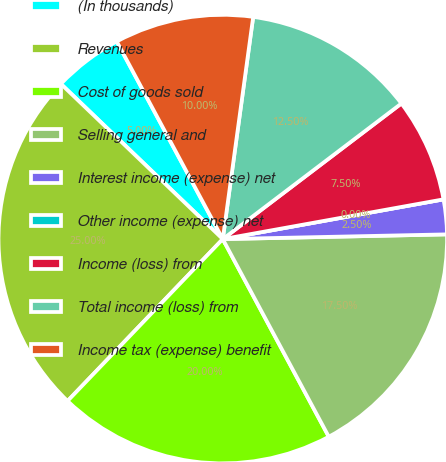Convert chart to OTSL. <chart><loc_0><loc_0><loc_500><loc_500><pie_chart><fcel>(In thousands)<fcel>Revenues<fcel>Cost of goods sold<fcel>Selling general and<fcel>Interest income (expense) net<fcel>Other income (expense) net<fcel>Income (loss) from<fcel>Total income (loss) from<fcel>Income tax (expense) benefit<nl><fcel>5.0%<fcel>25.0%<fcel>20.0%<fcel>17.5%<fcel>2.5%<fcel>0.0%<fcel>7.5%<fcel>12.5%<fcel>10.0%<nl></chart> 